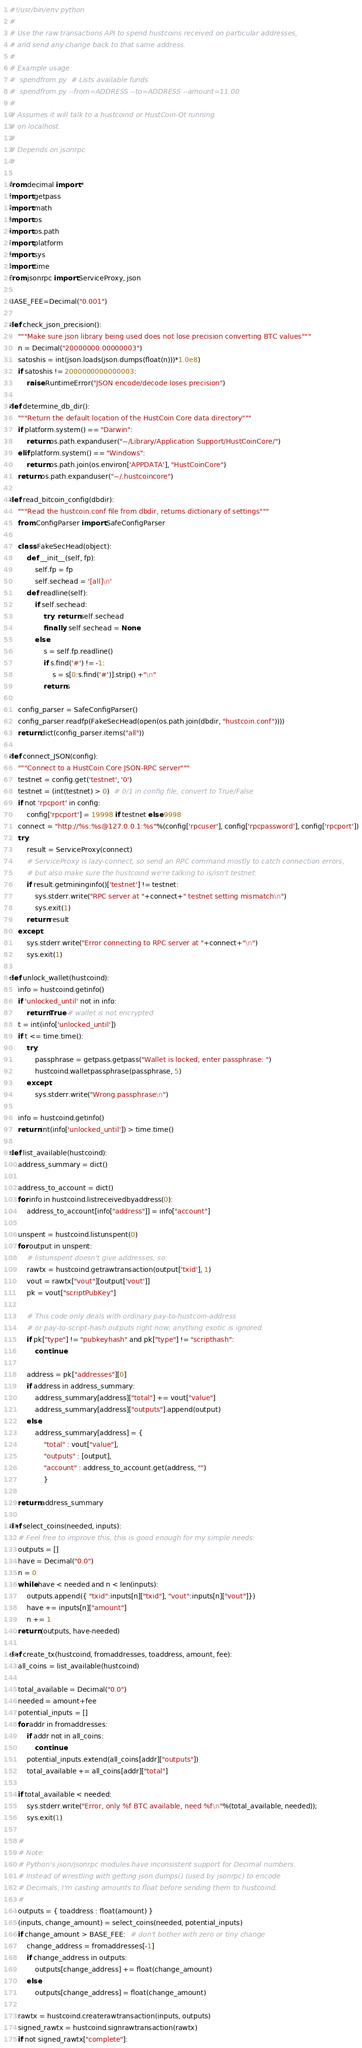Convert code to text. <code><loc_0><loc_0><loc_500><loc_500><_Python_>#!/usr/bin/env python
#
# Use the raw transactions API to spend hustcoins received on particular addresses,
# and send any change back to that same address.
#
# Example usage:
#  spendfrom.py  # Lists available funds
#  spendfrom.py --from=ADDRESS --to=ADDRESS --amount=11.00
#
# Assumes it will talk to a hustcoind or HustCoin-Qt running
# on localhost.
#
# Depends on jsonrpc
#

from decimal import *
import getpass
import math
import os
import os.path
import platform
import sys
import time
from jsonrpc import ServiceProxy, json

BASE_FEE=Decimal("0.001")

def check_json_precision():
    """Make sure json library being used does not lose precision converting BTC values"""
    n = Decimal("20000000.00000003")
    satoshis = int(json.loads(json.dumps(float(n)))*1.0e8)
    if satoshis != 2000000000000003:
        raise RuntimeError("JSON encode/decode loses precision")

def determine_db_dir():
    """Return the default location of the HustCoin Core data directory"""
    if platform.system() == "Darwin":
        return os.path.expanduser("~/Library/Application Support/HustCoinCore/")
    elif platform.system() == "Windows":
        return os.path.join(os.environ['APPDATA'], "HustCoinCore")
    return os.path.expanduser("~/.hustcoincore")

def read_bitcoin_config(dbdir):
    """Read the hustcoin.conf file from dbdir, returns dictionary of settings"""
    from ConfigParser import SafeConfigParser

    class FakeSecHead(object):
        def __init__(self, fp):
            self.fp = fp
            self.sechead = '[all]\n'
        def readline(self):
            if self.sechead:
                try: return self.sechead
                finally: self.sechead = None
            else:
                s = self.fp.readline()
                if s.find('#') != -1:
                    s = s[0:s.find('#')].strip() +"\n"
                return s

    config_parser = SafeConfigParser()
    config_parser.readfp(FakeSecHead(open(os.path.join(dbdir, "hustcoin.conf"))))
    return dict(config_parser.items("all"))

def connect_JSON(config):
    """Connect to a HustCoin Core JSON-RPC server"""
    testnet = config.get('testnet', '0')
    testnet = (int(testnet) > 0)  # 0/1 in config file, convert to True/False
    if not 'rpcport' in config:
        config['rpcport'] = 19998 if testnet else 9998
    connect = "http://%s:%s@127.0.0.1:%s"%(config['rpcuser'], config['rpcpassword'], config['rpcport'])
    try:
        result = ServiceProxy(connect)
        # ServiceProxy is lazy-connect, so send an RPC command mostly to catch connection errors,
        # but also make sure the hustcoind we're talking to is/isn't testnet:
        if result.getmininginfo()['testnet'] != testnet:
            sys.stderr.write("RPC server at "+connect+" testnet setting mismatch\n")
            sys.exit(1)
        return result
    except:
        sys.stderr.write("Error connecting to RPC server at "+connect+"\n")
        sys.exit(1)

def unlock_wallet(hustcoind):
    info = hustcoind.getinfo()
    if 'unlocked_until' not in info:
        return True # wallet is not encrypted
    t = int(info['unlocked_until'])
    if t <= time.time():
        try:
            passphrase = getpass.getpass("Wallet is locked; enter passphrase: ")
            hustcoind.walletpassphrase(passphrase, 5)
        except:
            sys.stderr.write("Wrong passphrase\n")

    info = hustcoind.getinfo()
    return int(info['unlocked_until']) > time.time()

def list_available(hustcoind):
    address_summary = dict()

    address_to_account = dict()
    for info in hustcoind.listreceivedbyaddress(0):
        address_to_account[info["address"]] = info["account"]

    unspent = hustcoind.listunspent(0)
    for output in unspent:
        # listunspent doesn't give addresses, so:
        rawtx = hustcoind.getrawtransaction(output['txid'], 1)
        vout = rawtx["vout"][output['vout']]
        pk = vout["scriptPubKey"]

        # This code only deals with ordinary pay-to-hustcoin-address
        # or pay-to-script-hash outputs right now; anything exotic is ignored.
        if pk["type"] != "pubkeyhash" and pk["type"] != "scripthash":
            continue

        address = pk["addresses"][0]
        if address in address_summary:
            address_summary[address]["total"] += vout["value"]
            address_summary[address]["outputs"].append(output)
        else:
            address_summary[address] = {
                "total" : vout["value"],
                "outputs" : [output],
                "account" : address_to_account.get(address, "")
                }

    return address_summary

def select_coins(needed, inputs):
    # Feel free to improve this, this is good enough for my simple needs:
    outputs = []
    have = Decimal("0.0")
    n = 0
    while have < needed and n < len(inputs):
        outputs.append({ "txid":inputs[n]["txid"], "vout":inputs[n]["vout"]})
        have += inputs[n]["amount"]
        n += 1
    return (outputs, have-needed)

def create_tx(hustcoind, fromaddresses, toaddress, amount, fee):
    all_coins = list_available(hustcoind)

    total_available = Decimal("0.0")
    needed = amount+fee
    potential_inputs = []
    for addr in fromaddresses:
        if addr not in all_coins:
            continue
        potential_inputs.extend(all_coins[addr]["outputs"])
        total_available += all_coins[addr]["total"]

    if total_available < needed:
        sys.stderr.write("Error, only %f BTC available, need %f\n"%(total_available, needed));
        sys.exit(1)

    #
    # Note:
    # Python's json/jsonrpc modules have inconsistent support for Decimal numbers.
    # Instead of wrestling with getting json.dumps() (used by jsonrpc) to encode
    # Decimals, I'm casting amounts to float before sending them to hustcoind.
    #
    outputs = { toaddress : float(amount) }
    (inputs, change_amount) = select_coins(needed, potential_inputs)
    if change_amount > BASE_FEE:  # don't bother with zero or tiny change
        change_address = fromaddresses[-1]
        if change_address in outputs:
            outputs[change_address] += float(change_amount)
        else:
            outputs[change_address] = float(change_amount)

    rawtx = hustcoind.createrawtransaction(inputs, outputs)
    signed_rawtx = hustcoind.signrawtransaction(rawtx)
    if not signed_rawtx["complete"]:</code> 